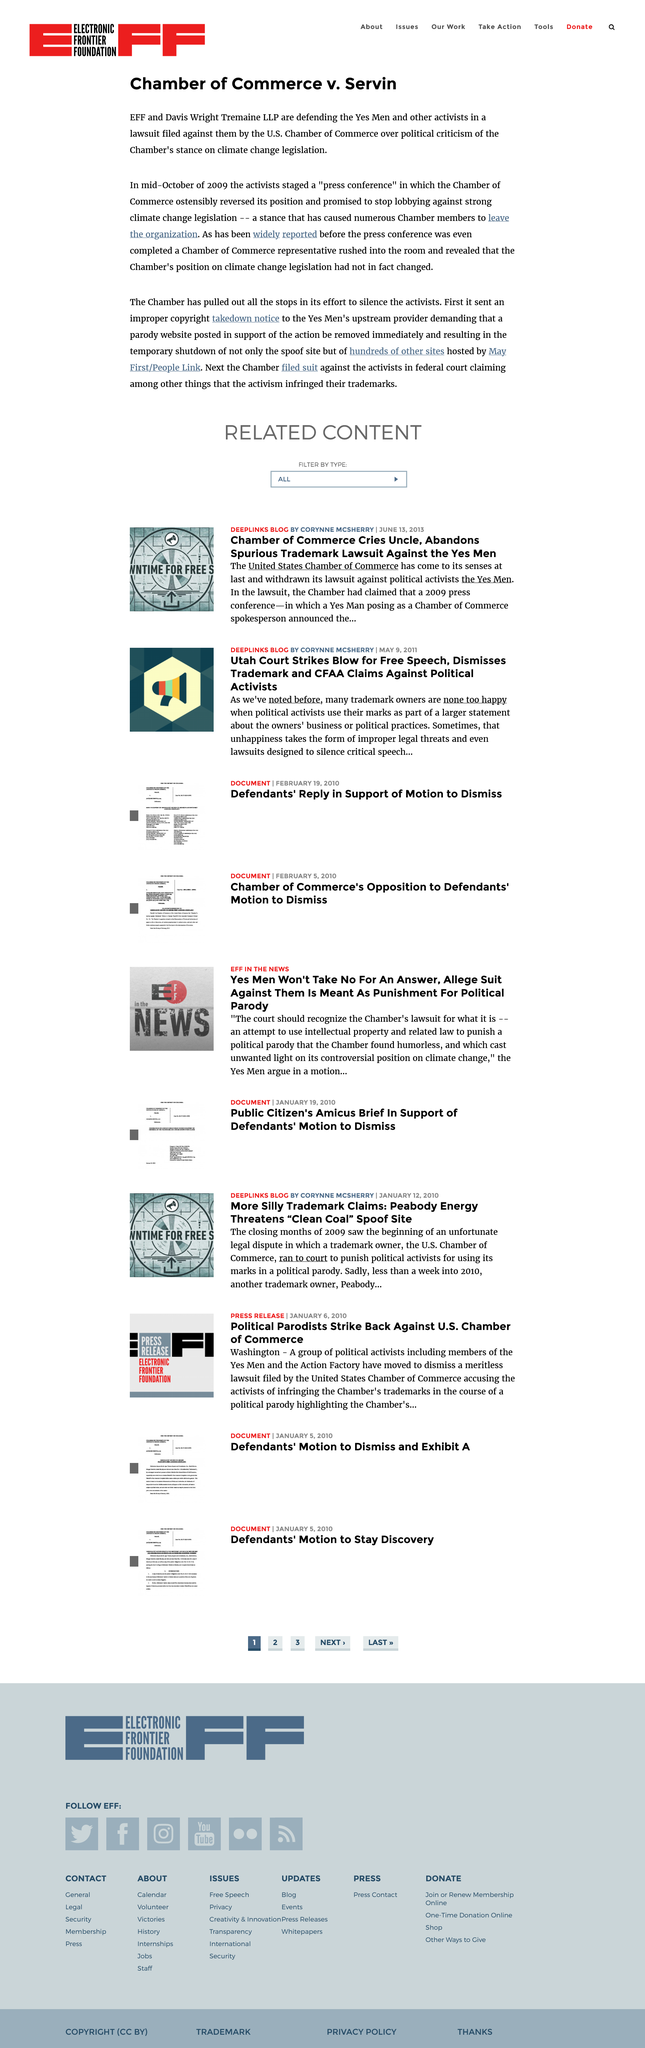Outline some significant characteristics in this image. In the case of Chamber of Commerce v. Servin, the plaintiff activists staged a fake press conference that caused the defendant Chamber of Commerce to take legal action against them. The Electronic Frontier Foundation (EFF) and Davis Wright Tremaine LLP are defending the activists in this situation. The fake press conference was held in mid-October 2009. 